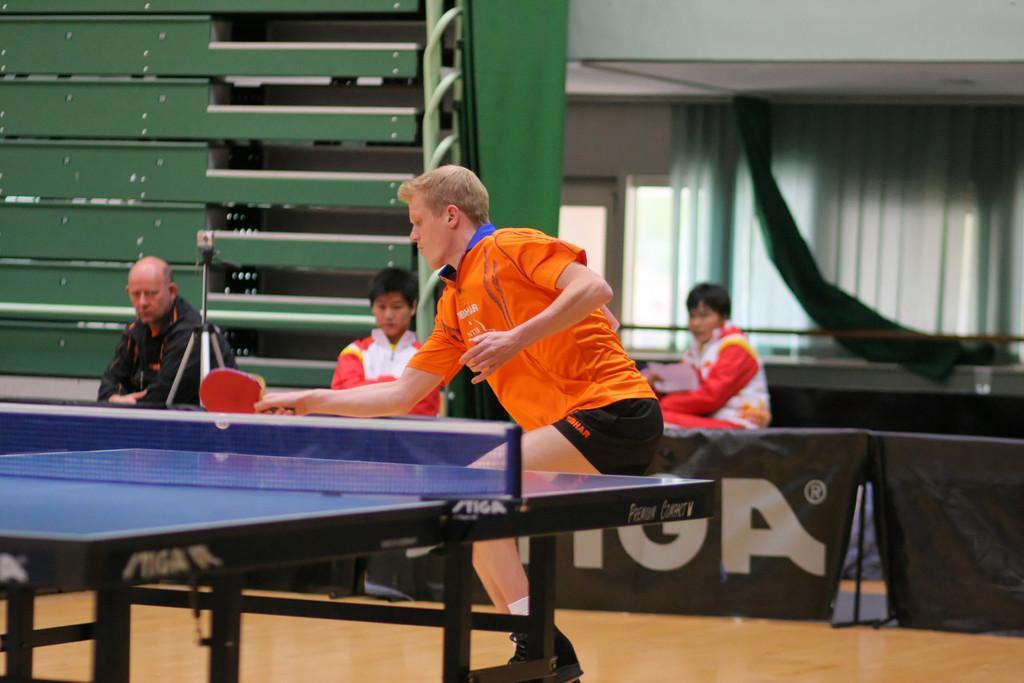Please provide a concise description of this image. There is a man playing table tennis in the image. He wore a orange jersey and is holding a table tennis racket. In front of him there is a table tennis table. Behind him there are three men watching the game and in front of them there is a black sheet used as board and there is also a tripod stand. In the background there is wall, curtains and railing. 